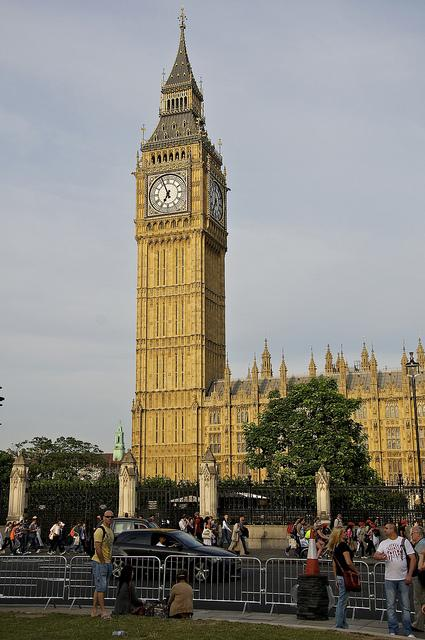The clock is reading five minutes before which hour? Please explain your reasoning. seven. The hour hand is closest to seven. 